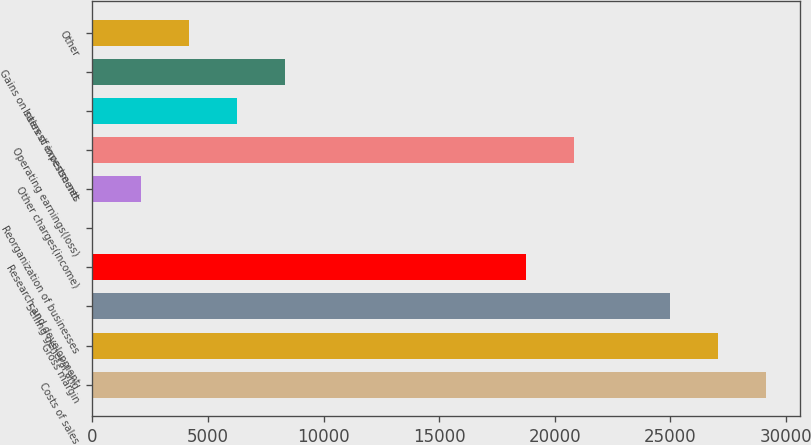Convert chart. <chart><loc_0><loc_0><loc_500><loc_500><bar_chart><fcel>Costs of sales<fcel>Gross margin<fcel>Selling general and<fcel>Research and development<fcel>Reorganization of businesses<fcel>Other charges(income)<fcel>Operating earnings(loss)<fcel>Interest expense net<fcel>Gains on sales of investments<fcel>Other<nl><fcel>29150.4<fcel>27069.3<fcel>24988.2<fcel>18744.9<fcel>15<fcel>2096.1<fcel>20826<fcel>6258.3<fcel>8339.4<fcel>4177.2<nl></chart> 